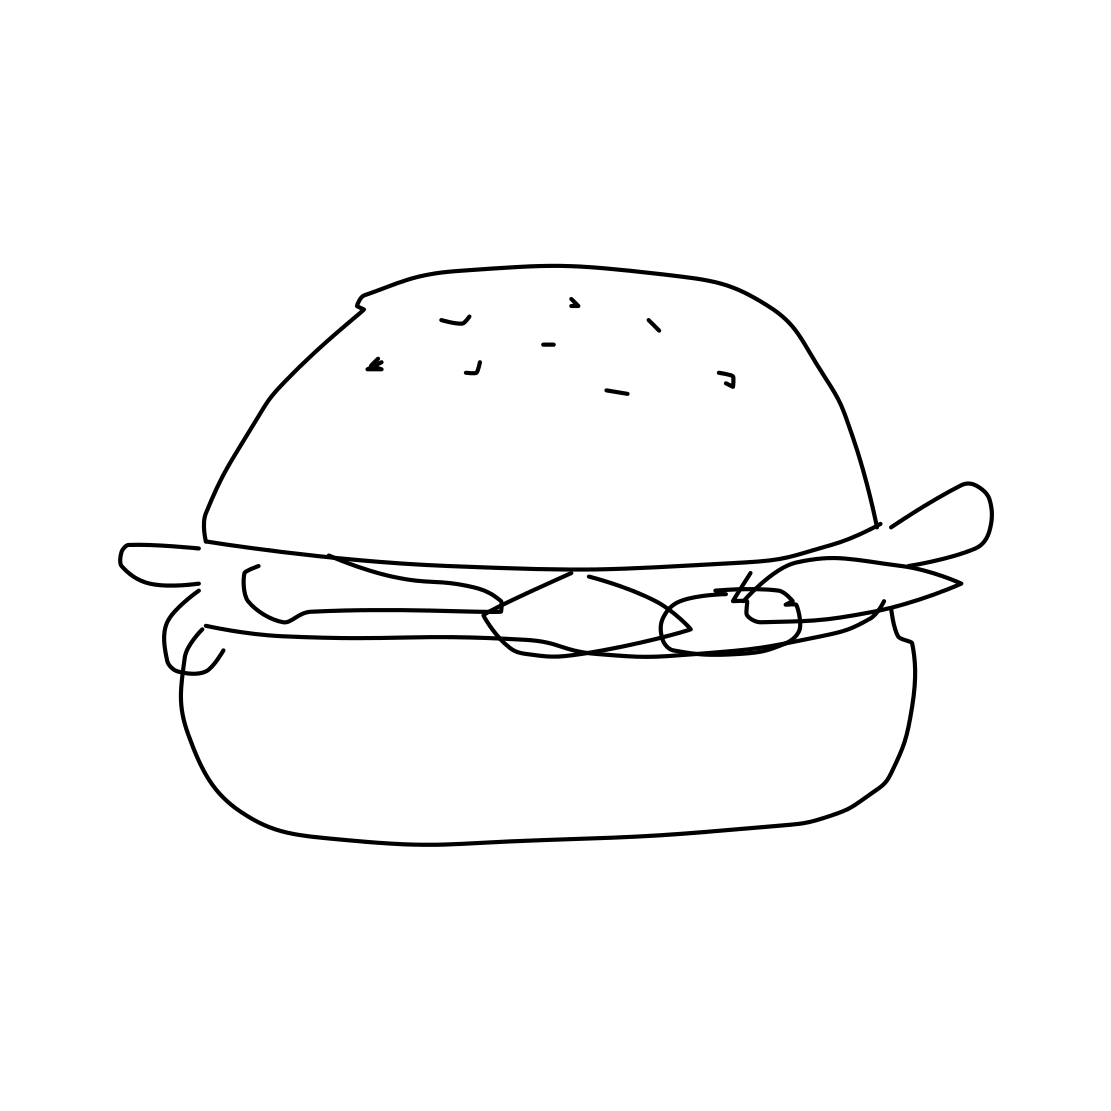In the scene, is a hamburger in it? Yes 